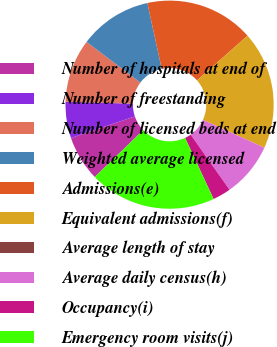Convert chart. <chart><loc_0><loc_0><loc_500><loc_500><pie_chart><fcel>Number of hospitals at end of<fcel>Number of freestanding<fcel>Number of licensed beds at end<fcel>Weighted average licensed<fcel>Admissions(e)<fcel>Equivalent admissions(f)<fcel>Average length of stay<fcel>Average daily census(h)<fcel>Occupancy(i)<fcel>Emergency room visits(j)<nl><fcel>7.04%<fcel>5.63%<fcel>9.86%<fcel>11.27%<fcel>16.9%<fcel>18.31%<fcel>0.0%<fcel>8.45%<fcel>2.82%<fcel>19.72%<nl></chart> 